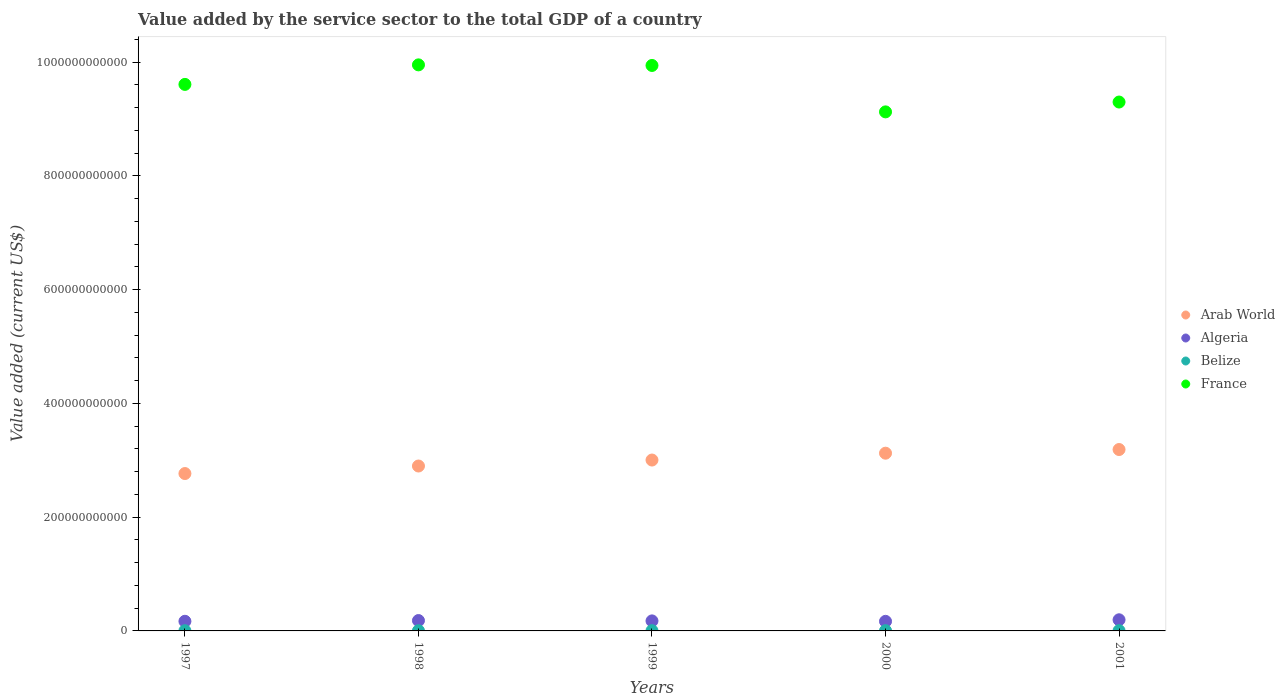What is the value added by the service sector to the total GDP in France in 2000?
Give a very brief answer. 9.13e+11. Across all years, what is the maximum value added by the service sector to the total GDP in Belize?
Make the answer very short. 4.84e+08. Across all years, what is the minimum value added by the service sector to the total GDP in Algeria?
Ensure brevity in your answer.  1.68e+1. In which year was the value added by the service sector to the total GDP in Belize minimum?
Provide a short and direct response. 1997. What is the total value added by the service sector to the total GDP in Algeria in the graph?
Offer a terse response. 8.92e+1. What is the difference between the value added by the service sector to the total GDP in Algeria in 2000 and that in 2001?
Give a very brief answer. -2.74e+09. What is the difference between the value added by the service sector to the total GDP in Arab World in 1998 and the value added by the service sector to the total GDP in Belize in 2001?
Make the answer very short. 2.89e+11. What is the average value added by the service sector to the total GDP in Arab World per year?
Keep it short and to the point. 3.00e+11. In the year 1999, what is the difference between the value added by the service sector to the total GDP in Belize and value added by the service sector to the total GDP in Algeria?
Ensure brevity in your answer.  -1.72e+1. In how many years, is the value added by the service sector to the total GDP in Algeria greater than 280000000000 US$?
Your answer should be compact. 0. What is the ratio of the value added by the service sector to the total GDP in Belize in 1997 to that in 1999?
Provide a short and direct response. 0.86. Is the difference between the value added by the service sector to the total GDP in Belize in 1998 and 2001 greater than the difference between the value added by the service sector to the total GDP in Algeria in 1998 and 2001?
Provide a succinct answer. Yes. What is the difference between the highest and the second highest value added by the service sector to the total GDP in France?
Your answer should be compact. 1.05e+09. What is the difference between the highest and the lowest value added by the service sector to the total GDP in Belize?
Your response must be concise. 1.34e+08. Is the sum of the value added by the service sector to the total GDP in Algeria in 1999 and 2000 greater than the maximum value added by the service sector to the total GDP in Arab World across all years?
Offer a terse response. No. Is it the case that in every year, the sum of the value added by the service sector to the total GDP in Belize and value added by the service sector to the total GDP in Algeria  is greater than the sum of value added by the service sector to the total GDP in Arab World and value added by the service sector to the total GDP in France?
Provide a succinct answer. No. Is the value added by the service sector to the total GDP in France strictly less than the value added by the service sector to the total GDP in Algeria over the years?
Offer a terse response. No. How many dotlines are there?
Provide a short and direct response. 4. How many years are there in the graph?
Make the answer very short. 5. What is the difference between two consecutive major ticks on the Y-axis?
Offer a terse response. 2.00e+11. Are the values on the major ticks of Y-axis written in scientific E-notation?
Your answer should be compact. No. How are the legend labels stacked?
Provide a succinct answer. Vertical. What is the title of the graph?
Keep it short and to the point. Value added by the service sector to the total GDP of a country. Does "Fragile and conflict affected situations" appear as one of the legend labels in the graph?
Give a very brief answer. No. What is the label or title of the X-axis?
Your answer should be very brief. Years. What is the label or title of the Y-axis?
Ensure brevity in your answer.  Value added (current US$). What is the Value added (current US$) of Arab World in 1997?
Provide a short and direct response. 2.77e+11. What is the Value added (current US$) in Algeria in 1997?
Provide a short and direct response. 1.69e+1. What is the Value added (current US$) of Belize in 1997?
Provide a short and direct response. 3.50e+08. What is the Value added (current US$) in France in 1997?
Your response must be concise. 9.61e+11. What is the Value added (current US$) of Arab World in 1998?
Provide a succinct answer. 2.90e+11. What is the Value added (current US$) of Algeria in 1998?
Your answer should be compact. 1.82e+1. What is the Value added (current US$) of Belize in 1998?
Your answer should be very brief. 3.70e+08. What is the Value added (current US$) of France in 1998?
Provide a succinct answer. 9.95e+11. What is the Value added (current US$) of Arab World in 1999?
Keep it short and to the point. 3.00e+11. What is the Value added (current US$) in Algeria in 1999?
Provide a short and direct response. 1.76e+1. What is the Value added (current US$) of Belize in 1999?
Your answer should be very brief. 4.06e+08. What is the Value added (current US$) of France in 1999?
Your response must be concise. 9.94e+11. What is the Value added (current US$) of Arab World in 2000?
Your answer should be very brief. 3.13e+11. What is the Value added (current US$) in Algeria in 2000?
Your response must be concise. 1.68e+1. What is the Value added (current US$) of Belize in 2000?
Provide a short and direct response. 4.52e+08. What is the Value added (current US$) of France in 2000?
Offer a very short reply. 9.13e+11. What is the Value added (current US$) in Arab World in 2001?
Your response must be concise. 3.19e+11. What is the Value added (current US$) in Algeria in 2001?
Provide a short and direct response. 1.96e+1. What is the Value added (current US$) of Belize in 2001?
Your response must be concise. 4.84e+08. What is the Value added (current US$) of France in 2001?
Provide a short and direct response. 9.30e+11. Across all years, what is the maximum Value added (current US$) in Arab World?
Keep it short and to the point. 3.19e+11. Across all years, what is the maximum Value added (current US$) in Algeria?
Your answer should be very brief. 1.96e+1. Across all years, what is the maximum Value added (current US$) of Belize?
Your answer should be very brief. 4.84e+08. Across all years, what is the maximum Value added (current US$) in France?
Give a very brief answer. 9.95e+11. Across all years, what is the minimum Value added (current US$) in Arab World?
Offer a terse response. 2.77e+11. Across all years, what is the minimum Value added (current US$) of Algeria?
Your response must be concise. 1.68e+1. Across all years, what is the minimum Value added (current US$) of Belize?
Keep it short and to the point. 3.50e+08. Across all years, what is the minimum Value added (current US$) in France?
Keep it short and to the point. 9.13e+11. What is the total Value added (current US$) of Arab World in the graph?
Your answer should be very brief. 1.50e+12. What is the total Value added (current US$) in Algeria in the graph?
Keep it short and to the point. 8.92e+1. What is the total Value added (current US$) in Belize in the graph?
Ensure brevity in your answer.  2.06e+09. What is the total Value added (current US$) in France in the graph?
Your response must be concise. 4.79e+12. What is the difference between the Value added (current US$) in Arab World in 1997 and that in 1998?
Make the answer very short. -1.32e+1. What is the difference between the Value added (current US$) in Algeria in 1997 and that in 1998?
Keep it short and to the point. -1.28e+09. What is the difference between the Value added (current US$) of Belize in 1997 and that in 1998?
Your response must be concise. -2.05e+07. What is the difference between the Value added (current US$) of France in 1997 and that in 1998?
Give a very brief answer. -3.43e+1. What is the difference between the Value added (current US$) in Arab World in 1997 and that in 1999?
Make the answer very short. -2.38e+1. What is the difference between the Value added (current US$) in Algeria in 1997 and that in 1999?
Provide a short and direct response. -6.76e+08. What is the difference between the Value added (current US$) in Belize in 1997 and that in 1999?
Offer a terse response. -5.60e+07. What is the difference between the Value added (current US$) in France in 1997 and that in 1999?
Ensure brevity in your answer.  -3.33e+1. What is the difference between the Value added (current US$) in Arab World in 1997 and that in 2000?
Give a very brief answer. -3.58e+1. What is the difference between the Value added (current US$) in Algeria in 1997 and that in 2000?
Your answer should be very brief. 1.05e+08. What is the difference between the Value added (current US$) of Belize in 1997 and that in 2000?
Keep it short and to the point. -1.02e+08. What is the difference between the Value added (current US$) of France in 1997 and that in 2000?
Give a very brief answer. 4.83e+1. What is the difference between the Value added (current US$) in Arab World in 1997 and that in 2001?
Your answer should be compact. -4.22e+1. What is the difference between the Value added (current US$) in Algeria in 1997 and that in 2001?
Ensure brevity in your answer.  -2.63e+09. What is the difference between the Value added (current US$) of Belize in 1997 and that in 2001?
Your answer should be compact. -1.34e+08. What is the difference between the Value added (current US$) in France in 1997 and that in 2001?
Make the answer very short. 3.10e+1. What is the difference between the Value added (current US$) of Arab World in 1998 and that in 1999?
Your answer should be compact. -1.05e+1. What is the difference between the Value added (current US$) of Algeria in 1998 and that in 1999?
Your answer should be very brief. 6.06e+08. What is the difference between the Value added (current US$) in Belize in 1998 and that in 1999?
Your answer should be very brief. -3.55e+07. What is the difference between the Value added (current US$) of France in 1998 and that in 1999?
Keep it short and to the point. 1.05e+09. What is the difference between the Value added (current US$) of Arab World in 1998 and that in 2000?
Provide a succinct answer. -2.26e+1. What is the difference between the Value added (current US$) of Algeria in 1998 and that in 2000?
Keep it short and to the point. 1.39e+09. What is the difference between the Value added (current US$) in Belize in 1998 and that in 2000?
Offer a very short reply. -8.13e+07. What is the difference between the Value added (current US$) of France in 1998 and that in 2000?
Offer a terse response. 8.27e+1. What is the difference between the Value added (current US$) in Arab World in 1998 and that in 2001?
Ensure brevity in your answer.  -2.90e+1. What is the difference between the Value added (current US$) in Algeria in 1998 and that in 2001?
Ensure brevity in your answer.  -1.35e+09. What is the difference between the Value added (current US$) in Belize in 1998 and that in 2001?
Ensure brevity in your answer.  -1.14e+08. What is the difference between the Value added (current US$) in France in 1998 and that in 2001?
Provide a short and direct response. 6.54e+1. What is the difference between the Value added (current US$) of Arab World in 1999 and that in 2000?
Your answer should be very brief. -1.20e+1. What is the difference between the Value added (current US$) of Algeria in 1999 and that in 2000?
Provide a short and direct response. 7.81e+08. What is the difference between the Value added (current US$) in Belize in 1999 and that in 2000?
Offer a very short reply. -4.58e+07. What is the difference between the Value added (current US$) of France in 1999 and that in 2000?
Provide a short and direct response. 8.16e+1. What is the difference between the Value added (current US$) of Arab World in 1999 and that in 2001?
Offer a very short reply. -1.85e+1. What is the difference between the Value added (current US$) in Algeria in 1999 and that in 2001?
Offer a terse response. -1.96e+09. What is the difference between the Value added (current US$) of Belize in 1999 and that in 2001?
Your answer should be very brief. -7.84e+07. What is the difference between the Value added (current US$) in France in 1999 and that in 2001?
Give a very brief answer. 6.43e+1. What is the difference between the Value added (current US$) of Arab World in 2000 and that in 2001?
Your response must be concise. -6.45e+09. What is the difference between the Value added (current US$) of Algeria in 2000 and that in 2001?
Your answer should be compact. -2.74e+09. What is the difference between the Value added (current US$) of Belize in 2000 and that in 2001?
Keep it short and to the point. -3.26e+07. What is the difference between the Value added (current US$) in France in 2000 and that in 2001?
Give a very brief answer. -1.73e+1. What is the difference between the Value added (current US$) of Arab World in 1997 and the Value added (current US$) of Algeria in 1998?
Ensure brevity in your answer.  2.59e+11. What is the difference between the Value added (current US$) of Arab World in 1997 and the Value added (current US$) of Belize in 1998?
Give a very brief answer. 2.76e+11. What is the difference between the Value added (current US$) in Arab World in 1997 and the Value added (current US$) in France in 1998?
Keep it short and to the point. -7.19e+11. What is the difference between the Value added (current US$) in Algeria in 1997 and the Value added (current US$) in Belize in 1998?
Your answer should be very brief. 1.66e+1. What is the difference between the Value added (current US$) of Algeria in 1997 and the Value added (current US$) of France in 1998?
Give a very brief answer. -9.78e+11. What is the difference between the Value added (current US$) in Belize in 1997 and the Value added (current US$) in France in 1998?
Give a very brief answer. -9.95e+11. What is the difference between the Value added (current US$) in Arab World in 1997 and the Value added (current US$) in Algeria in 1999?
Offer a very short reply. 2.59e+11. What is the difference between the Value added (current US$) in Arab World in 1997 and the Value added (current US$) in Belize in 1999?
Offer a terse response. 2.76e+11. What is the difference between the Value added (current US$) of Arab World in 1997 and the Value added (current US$) of France in 1999?
Ensure brevity in your answer.  -7.18e+11. What is the difference between the Value added (current US$) in Algeria in 1997 and the Value added (current US$) in Belize in 1999?
Keep it short and to the point. 1.65e+1. What is the difference between the Value added (current US$) in Algeria in 1997 and the Value added (current US$) in France in 1999?
Ensure brevity in your answer.  -9.77e+11. What is the difference between the Value added (current US$) in Belize in 1997 and the Value added (current US$) in France in 1999?
Your answer should be very brief. -9.94e+11. What is the difference between the Value added (current US$) in Arab World in 1997 and the Value added (current US$) in Algeria in 2000?
Your answer should be very brief. 2.60e+11. What is the difference between the Value added (current US$) in Arab World in 1997 and the Value added (current US$) in Belize in 2000?
Your response must be concise. 2.76e+11. What is the difference between the Value added (current US$) in Arab World in 1997 and the Value added (current US$) in France in 2000?
Keep it short and to the point. -6.36e+11. What is the difference between the Value added (current US$) in Algeria in 1997 and the Value added (current US$) in Belize in 2000?
Your response must be concise. 1.65e+1. What is the difference between the Value added (current US$) of Algeria in 1997 and the Value added (current US$) of France in 2000?
Your answer should be compact. -8.96e+11. What is the difference between the Value added (current US$) of Belize in 1997 and the Value added (current US$) of France in 2000?
Your answer should be very brief. -9.12e+11. What is the difference between the Value added (current US$) in Arab World in 1997 and the Value added (current US$) in Algeria in 2001?
Your answer should be compact. 2.57e+11. What is the difference between the Value added (current US$) of Arab World in 1997 and the Value added (current US$) of Belize in 2001?
Give a very brief answer. 2.76e+11. What is the difference between the Value added (current US$) in Arab World in 1997 and the Value added (current US$) in France in 2001?
Offer a very short reply. -6.53e+11. What is the difference between the Value added (current US$) in Algeria in 1997 and the Value added (current US$) in Belize in 2001?
Offer a terse response. 1.65e+1. What is the difference between the Value added (current US$) in Algeria in 1997 and the Value added (current US$) in France in 2001?
Keep it short and to the point. -9.13e+11. What is the difference between the Value added (current US$) of Belize in 1997 and the Value added (current US$) of France in 2001?
Provide a succinct answer. -9.30e+11. What is the difference between the Value added (current US$) of Arab World in 1998 and the Value added (current US$) of Algeria in 1999?
Give a very brief answer. 2.72e+11. What is the difference between the Value added (current US$) of Arab World in 1998 and the Value added (current US$) of Belize in 1999?
Your response must be concise. 2.90e+11. What is the difference between the Value added (current US$) in Arab World in 1998 and the Value added (current US$) in France in 1999?
Your response must be concise. -7.04e+11. What is the difference between the Value added (current US$) in Algeria in 1998 and the Value added (current US$) in Belize in 1999?
Your answer should be compact. 1.78e+1. What is the difference between the Value added (current US$) in Algeria in 1998 and the Value added (current US$) in France in 1999?
Your response must be concise. -9.76e+11. What is the difference between the Value added (current US$) of Belize in 1998 and the Value added (current US$) of France in 1999?
Give a very brief answer. -9.94e+11. What is the difference between the Value added (current US$) in Arab World in 1998 and the Value added (current US$) in Algeria in 2000?
Ensure brevity in your answer.  2.73e+11. What is the difference between the Value added (current US$) in Arab World in 1998 and the Value added (current US$) in Belize in 2000?
Make the answer very short. 2.90e+11. What is the difference between the Value added (current US$) of Arab World in 1998 and the Value added (current US$) of France in 2000?
Your answer should be compact. -6.23e+11. What is the difference between the Value added (current US$) in Algeria in 1998 and the Value added (current US$) in Belize in 2000?
Give a very brief answer. 1.78e+1. What is the difference between the Value added (current US$) of Algeria in 1998 and the Value added (current US$) of France in 2000?
Your answer should be compact. -8.94e+11. What is the difference between the Value added (current US$) in Belize in 1998 and the Value added (current US$) in France in 2000?
Your answer should be compact. -9.12e+11. What is the difference between the Value added (current US$) of Arab World in 1998 and the Value added (current US$) of Algeria in 2001?
Keep it short and to the point. 2.70e+11. What is the difference between the Value added (current US$) in Arab World in 1998 and the Value added (current US$) in Belize in 2001?
Offer a very short reply. 2.89e+11. What is the difference between the Value added (current US$) of Arab World in 1998 and the Value added (current US$) of France in 2001?
Your answer should be very brief. -6.40e+11. What is the difference between the Value added (current US$) of Algeria in 1998 and the Value added (current US$) of Belize in 2001?
Give a very brief answer. 1.77e+1. What is the difference between the Value added (current US$) of Algeria in 1998 and the Value added (current US$) of France in 2001?
Keep it short and to the point. -9.12e+11. What is the difference between the Value added (current US$) of Belize in 1998 and the Value added (current US$) of France in 2001?
Offer a terse response. -9.30e+11. What is the difference between the Value added (current US$) of Arab World in 1999 and the Value added (current US$) of Algeria in 2000?
Make the answer very short. 2.84e+11. What is the difference between the Value added (current US$) of Arab World in 1999 and the Value added (current US$) of Belize in 2000?
Provide a short and direct response. 3.00e+11. What is the difference between the Value added (current US$) in Arab World in 1999 and the Value added (current US$) in France in 2000?
Give a very brief answer. -6.12e+11. What is the difference between the Value added (current US$) in Algeria in 1999 and the Value added (current US$) in Belize in 2000?
Offer a terse response. 1.72e+1. What is the difference between the Value added (current US$) of Algeria in 1999 and the Value added (current US$) of France in 2000?
Your answer should be compact. -8.95e+11. What is the difference between the Value added (current US$) in Belize in 1999 and the Value added (current US$) in France in 2000?
Offer a terse response. -9.12e+11. What is the difference between the Value added (current US$) of Arab World in 1999 and the Value added (current US$) of Algeria in 2001?
Your response must be concise. 2.81e+11. What is the difference between the Value added (current US$) in Arab World in 1999 and the Value added (current US$) in Belize in 2001?
Make the answer very short. 3.00e+11. What is the difference between the Value added (current US$) of Arab World in 1999 and the Value added (current US$) of France in 2001?
Offer a terse response. -6.30e+11. What is the difference between the Value added (current US$) in Algeria in 1999 and the Value added (current US$) in Belize in 2001?
Provide a short and direct response. 1.71e+1. What is the difference between the Value added (current US$) of Algeria in 1999 and the Value added (current US$) of France in 2001?
Your answer should be compact. -9.12e+11. What is the difference between the Value added (current US$) in Belize in 1999 and the Value added (current US$) in France in 2001?
Offer a very short reply. -9.30e+11. What is the difference between the Value added (current US$) of Arab World in 2000 and the Value added (current US$) of Algeria in 2001?
Provide a short and direct response. 2.93e+11. What is the difference between the Value added (current US$) in Arab World in 2000 and the Value added (current US$) in Belize in 2001?
Make the answer very short. 3.12e+11. What is the difference between the Value added (current US$) of Arab World in 2000 and the Value added (current US$) of France in 2001?
Make the answer very short. -6.17e+11. What is the difference between the Value added (current US$) in Algeria in 2000 and the Value added (current US$) in Belize in 2001?
Offer a terse response. 1.64e+1. What is the difference between the Value added (current US$) of Algeria in 2000 and the Value added (current US$) of France in 2001?
Offer a terse response. -9.13e+11. What is the difference between the Value added (current US$) of Belize in 2000 and the Value added (current US$) of France in 2001?
Ensure brevity in your answer.  -9.30e+11. What is the average Value added (current US$) in Arab World per year?
Keep it short and to the point. 3.00e+11. What is the average Value added (current US$) of Algeria per year?
Provide a short and direct response. 1.78e+1. What is the average Value added (current US$) of Belize per year?
Keep it short and to the point. 4.12e+08. What is the average Value added (current US$) of France per year?
Provide a short and direct response. 9.59e+11. In the year 1997, what is the difference between the Value added (current US$) of Arab World and Value added (current US$) of Algeria?
Make the answer very short. 2.60e+11. In the year 1997, what is the difference between the Value added (current US$) of Arab World and Value added (current US$) of Belize?
Offer a very short reply. 2.76e+11. In the year 1997, what is the difference between the Value added (current US$) of Arab World and Value added (current US$) of France?
Offer a very short reply. -6.84e+11. In the year 1997, what is the difference between the Value added (current US$) in Algeria and Value added (current US$) in Belize?
Offer a terse response. 1.66e+1. In the year 1997, what is the difference between the Value added (current US$) in Algeria and Value added (current US$) in France?
Provide a short and direct response. -9.44e+11. In the year 1997, what is the difference between the Value added (current US$) in Belize and Value added (current US$) in France?
Your answer should be very brief. -9.61e+11. In the year 1998, what is the difference between the Value added (current US$) of Arab World and Value added (current US$) of Algeria?
Your answer should be compact. 2.72e+11. In the year 1998, what is the difference between the Value added (current US$) in Arab World and Value added (current US$) in Belize?
Give a very brief answer. 2.90e+11. In the year 1998, what is the difference between the Value added (current US$) of Arab World and Value added (current US$) of France?
Give a very brief answer. -7.05e+11. In the year 1998, what is the difference between the Value added (current US$) in Algeria and Value added (current US$) in Belize?
Your answer should be very brief. 1.79e+1. In the year 1998, what is the difference between the Value added (current US$) of Algeria and Value added (current US$) of France?
Ensure brevity in your answer.  -9.77e+11. In the year 1998, what is the difference between the Value added (current US$) of Belize and Value added (current US$) of France?
Provide a short and direct response. -9.95e+11. In the year 1999, what is the difference between the Value added (current US$) in Arab World and Value added (current US$) in Algeria?
Provide a short and direct response. 2.83e+11. In the year 1999, what is the difference between the Value added (current US$) in Arab World and Value added (current US$) in Belize?
Provide a short and direct response. 3.00e+11. In the year 1999, what is the difference between the Value added (current US$) of Arab World and Value added (current US$) of France?
Make the answer very short. -6.94e+11. In the year 1999, what is the difference between the Value added (current US$) of Algeria and Value added (current US$) of Belize?
Your response must be concise. 1.72e+1. In the year 1999, what is the difference between the Value added (current US$) of Algeria and Value added (current US$) of France?
Offer a very short reply. -9.77e+11. In the year 1999, what is the difference between the Value added (current US$) of Belize and Value added (current US$) of France?
Your answer should be very brief. -9.94e+11. In the year 2000, what is the difference between the Value added (current US$) of Arab World and Value added (current US$) of Algeria?
Give a very brief answer. 2.96e+11. In the year 2000, what is the difference between the Value added (current US$) of Arab World and Value added (current US$) of Belize?
Provide a short and direct response. 3.12e+11. In the year 2000, what is the difference between the Value added (current US$) of Arab World and Value added (current US$) of France?
Provide a succinct answer. -6.00e+11. In the year 2000, what is the difference between the Value added (current US$) in Algeria and Value added (current US$) in Belize?
Give a very brief answer. 1.64e+1. In the year 2000, what is the difference between the Value added (current US$) in Algeria and Value added (current US$) in France?
Your answer should be very brief. -8.96e+11. In the year 2000, what is the difference between the Value added (current US$) in Belize and Value added (current US$) in France?
Give a very brief answer. -9.12e+11. In the year 2001, what is the difference between the Value added (current US$) of Arab World and Value added (current US$) of Algeria?
Make the answer very short. 2.99e+11. In the year 2001, what is the difference between the Value added (current US$) in Arab World and Value added (current US$) in Belize?
Ensure brevity in your answer.  3.18e+11. In the year 2001, what is the difference between the Value added (current US$) in Arab World and Value added (current US$) in France?
Ensure brevity in your answer.  -6.11e+11. In the year 2001, what is the difference between the Value added (current US$) of Algeria and Value added (current US$) of Belize?
Give a very brief answer. 1.91e+1. In the year 2001, what is the difference between the Value added (current US$) in Algeria and Value added (current US$) in France?
Your response must be concise. -9.10e+11. In the year 2001, what is the difference between the Value added (current US$) in Belize and Value added (current US$) in France?
Your response must be concise. -9.30e+11. What is the ratio of the Value added (current US$) of Arab World in 1997 to that in 1998?
Provide a succinct answer. 0.95. What is the ratio of the Value added (current US$) of Algeria in 1997 to that in 1998?
Offer a very short reply. 0.93. What is the ratio of the Value added (current US$) in Belize in 1997 to that in 1998?
Offer a terse response. 0.94. What is the ratio of the Value added (current US$) of France in 1997 to that in 1998?
Make the answer very short. 0.97. What is the ratio of the Value added (current US$) of Arab World in 1997 to that in 1999?
Your response must be concise. 0.92. What is the ratio of the Value added (current US$) of Algeria in 1997 to that in 1999?
Offer a terse response. 0.96. What is the ratio of the Value added (current US$) of Belize in 1997 to that in 1999?
Provide a succinct answer. 0.86. What is the ratio of the Value added (current US$) in France in 1997 to that in 1999?
Your answer should be compact. 0.97. What is the ratio of the Value added (current US$) of Arab World in 1997 to that in 2000?
Make the answer very short. 0.89. What is the ratio of the Value added (current US$) in Belize in 1997 to that in 2000?
Your response must be concise. 0.77. What is the ratio of the Value added (current US$) in France in 1997 to that in 2000?
Provide a succinct answer. 1.05. What is the ratio of the Value added (current US$) of Arab World in 1997 to that in 2001?
Keep it short and to the point. 0.87. What is the ratio of the Value added (current US$) of Algeria in 1997 to that in 2001?
Give a very brief answer. 0.87. What is the ratio of the Value added (current US$) in Belize in 1997 to that in 2001?
Your answer should be compact. 0.72. What is the ratio of the Value added (current US$) of France in 1997 to that in 2001?
Keep it short and to the point. 1.03. What is the ratio of the Value added (current US$) of Arab World in 1998 to that in 1999?
Provide a succinct answer. 0.96. What is the ratio of the Value added (current US$) in Algeria in 1998 to that in 1999?
Give a very brief answer. 1.03. What is the ratio of the Value added (current US$) in Belize in 1998 to that in 1999?
Keep it short and to the point. 0.91. What is the ratio of the Value added (current US$) in Arab World in 1998 to that in 2000?
Give a very brief answer. 0.93. What is the ratio of the Value added (current US$) in Algeria in 1998 to that in 2000?
Make the answer very short. 1.08. What is the ratio of the Value added (current US$) of Belize in 1998 to that in 2000?
Your answer should be compact. 0.82. What is the ratio of the Value added (current US$) of France in 1998 to that in 2000?
Provide a short and direct response. 1.09. What is the ratio of the Value added (current US$) of Arab World in 1998 to that in 2001?
Give a very brief answer. 0.91. What is the ratio of the Value added (current US$) of Belize in 1998 to that in 2001?
Give a very brief answer. 0.76. What is the ratio of the Value added (current US$) of France in 1998 to that in 2001?
Your response must be concise. 1.07. What is the ratio of the Value added (current US$) of Arab World in 1999 to that in 2000?
Provide a short and direct response. 0.96. What is the ratio of the Value added (current US$) of Algeria in 1999 to that in 2000?
Ensure brevity in your answer.  1.05. What is the ratio of the Value added (current US$) of Belize in 1999 to that in 2000?
Your answer should be very brief. 0.9. What is the ratio of the Value added (current US$) in France in 1999 to that in 2000?
Keep it short and to the point. 1.09. What is the ratio of the Value added (current US$) of Arab World in 1999 to that in 2001?
Ensure brevity in your answer.  0.94. What is the ratio of the Value added (current US$) in Algeria in 1999 to that in 2001?
Offer a very short reply. 0.9. What is the ratio of the Value added (current US$) of Belize in 1999 to that in 2001?
Provide a short and direct response. 0.84. What is the ratio of the Value added (current US$) in France in 1999 to that in 2001?
Your answer should be compact. 1.07. What is the ratio of the Value added (current US$) in Arab World in 2000 to that in 2001?
Give a very brief answer. 0.98. What is the ratio of the Value added (current US$) in Algeria in 2000 to that in 2001?
Make the answer very short. 0.86. What is the ratio of the Value added (current US$) in Belize in 2000 to that in 2001?
Your answer should be compact. 0.93. What is the ratio of the Value added (current US$) of France in 2000 to that in 2001?
Offer a very short reply. 0.98. What is the difference between the highest and the second highest Value added (current US$) of Arab World?
Your response must be concise. 6.45e+09. What is the difference between the highest and the second highest Value added (current US$) in Algeria?
Provide a short and direct response. 1.35e+09. What is the difference between the highest and the second highest Value added (current US$) of Belize?
Offer a very short reply. 3.26e+07. What is the difference between the highest and the second highest Value added (current US$) of France?
Make the answer very short. 1.05e+09. What is the difference between the highest and the lowest Value added (current US$) of Arab World?
Your response must be concise. 4.22e+1. What is the difference between the highest and the lowest Value added (current US$) of Algeria?
Offer a terse response. 2.74e+09. What is the difference between the highest and the lowest Value added (current US$) in Belize?
Your response must be concise. 1.34e+08. What is the difference between the highest and the lowest Value added (current US$) of France?
Offer a terse response. 8.27e+1. 